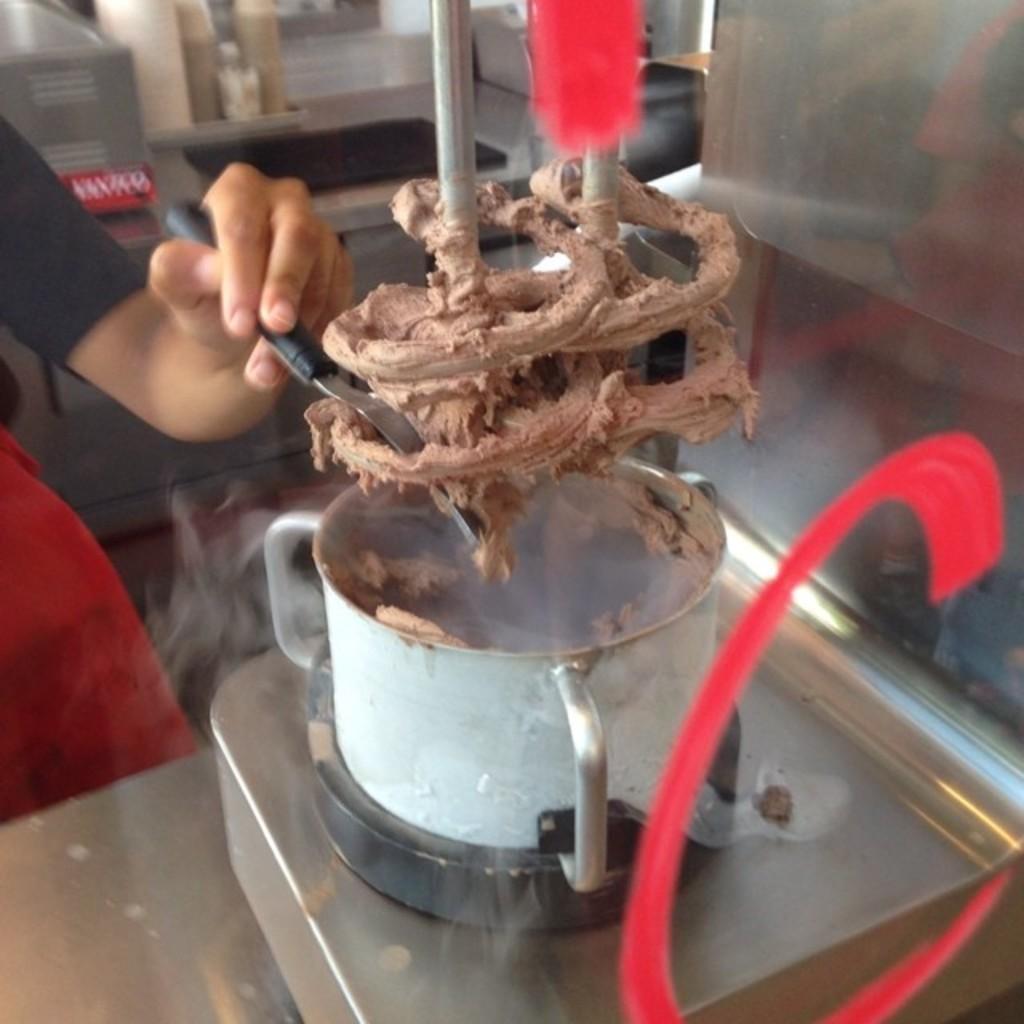Please provide a concise description of this image. In this image there is a machine, in front of that there is a person holding an object, behind the person there are so many objects. 